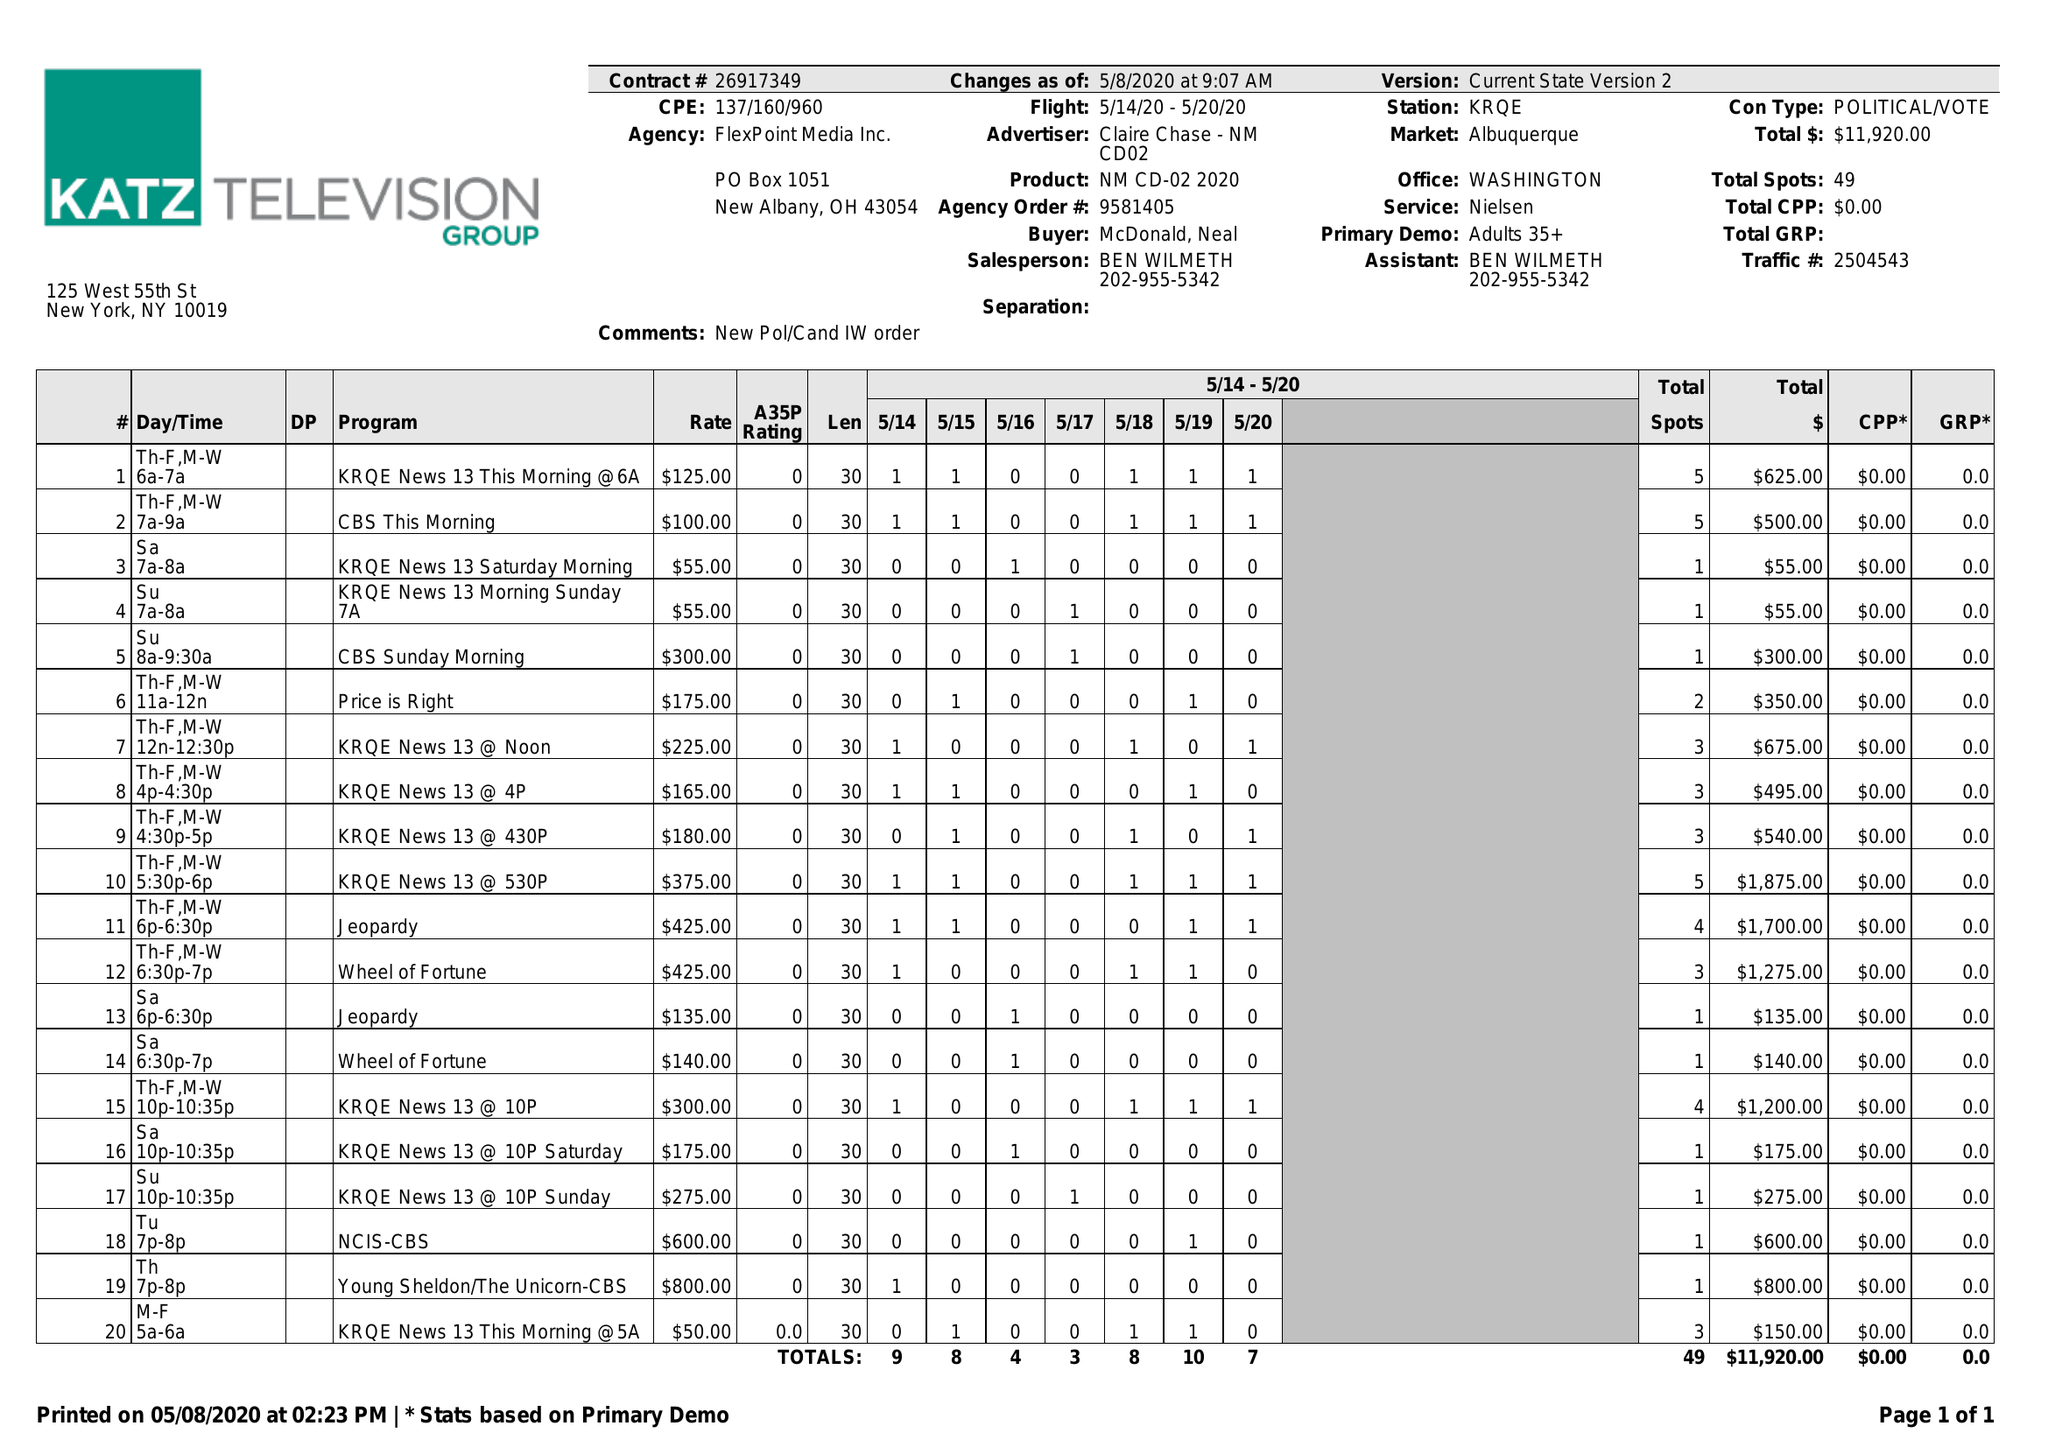What is the value for the contract_num?
Answer the question using a single word or phrase. 26917349 